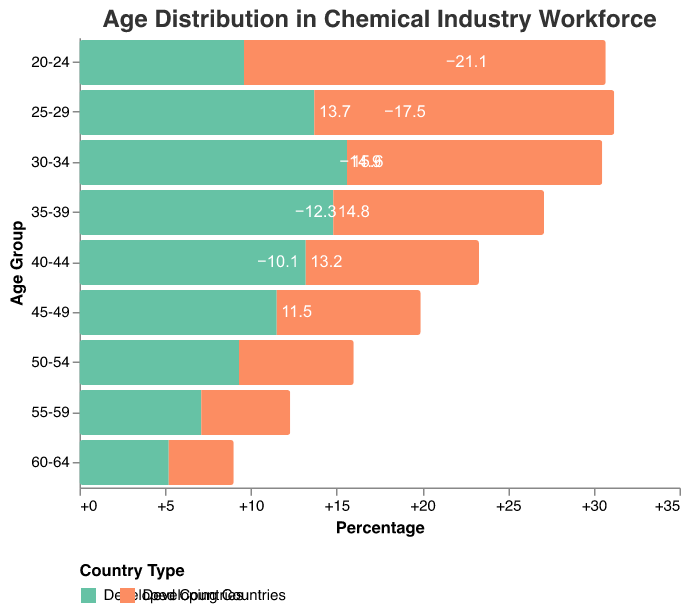What does the title of the figure indicate? The title of the figure is "Age Distribution in Chemical Industry Workforce," indicating that the figure displays the age distribution of workers in the chemical industry, comparing developed and developing countries.
Answer: Age Distribution in Chemical Industry Workforce Which country type has the largest percentage of workers in the 30-34 age group? By examining the bars corresponding to the 30-34 age group, it is evident that the developed countries have the largest percentage, at 15.6%, compared to the developing countries.
Answer: Developed countries What is the percentage difference between workers aged 25-29 in developing and developed countries? The percentage of workers aged 25-29 is 13.7% in developed countries and -17.5% in developing countries. The difference is calculated as 17.5% - 13.7% = 3.8% (absolute difference).
Answer: 3.8% Between which age groups is the percentage of workforce in developing countries the lowest? The lowest percentage is for the 20-24 age group in developing countries, shown as -21.1% on the figure.
Answer: 20-24 How do the percentages compare for the 45-49 age group between developed and developing countries? The bar for the 45-49 age group shows 11.5% for developed countries and -8.4% for developing countries. The percentage for developed countries is higher.
Answer: Developed > Developing What is the cumulative percentage of the workforce for the 30-39 age groups in developed countries? The 30-34 age group has 15.6% and the 35-39 age group has 14.8%. Adding these percentages gives 15.6% + 14.8% = 30.4%.
Answer: 30.4% Identify the age group with the highest percentage for developing countries. The highest percentage for developing countries is in the 20-24 age group, shown as -21.1% on the figure.
Answer: 20-24 What trend can be observed in the age distribution for developing countries as the age groups increase from 20-24 to 60-64? The percentages start high at -21.1% for the 20-24 age group and gradually decrease, indicating a downward trend in percentages as the age groups increase.
Answer: Downward trend Which age group shows an equal percentage difference of 4.2% between the two country types? The 55-59 age group has a percentage of 7.1% for developed countries and -5.2% for developing countries. The difference is 7.1 - (-5.2) = 12.3% (not 4.2%). No age group shows a 4.2% difference.
Answer: None How does the percentage of workers aged 50-54 compare between the two country types? The percentage for the 50-54 age group is 9.3% in developed countries and -6.7% in developing countries. The percentage in developed countries is higher.
Answer: Developed > Developing 